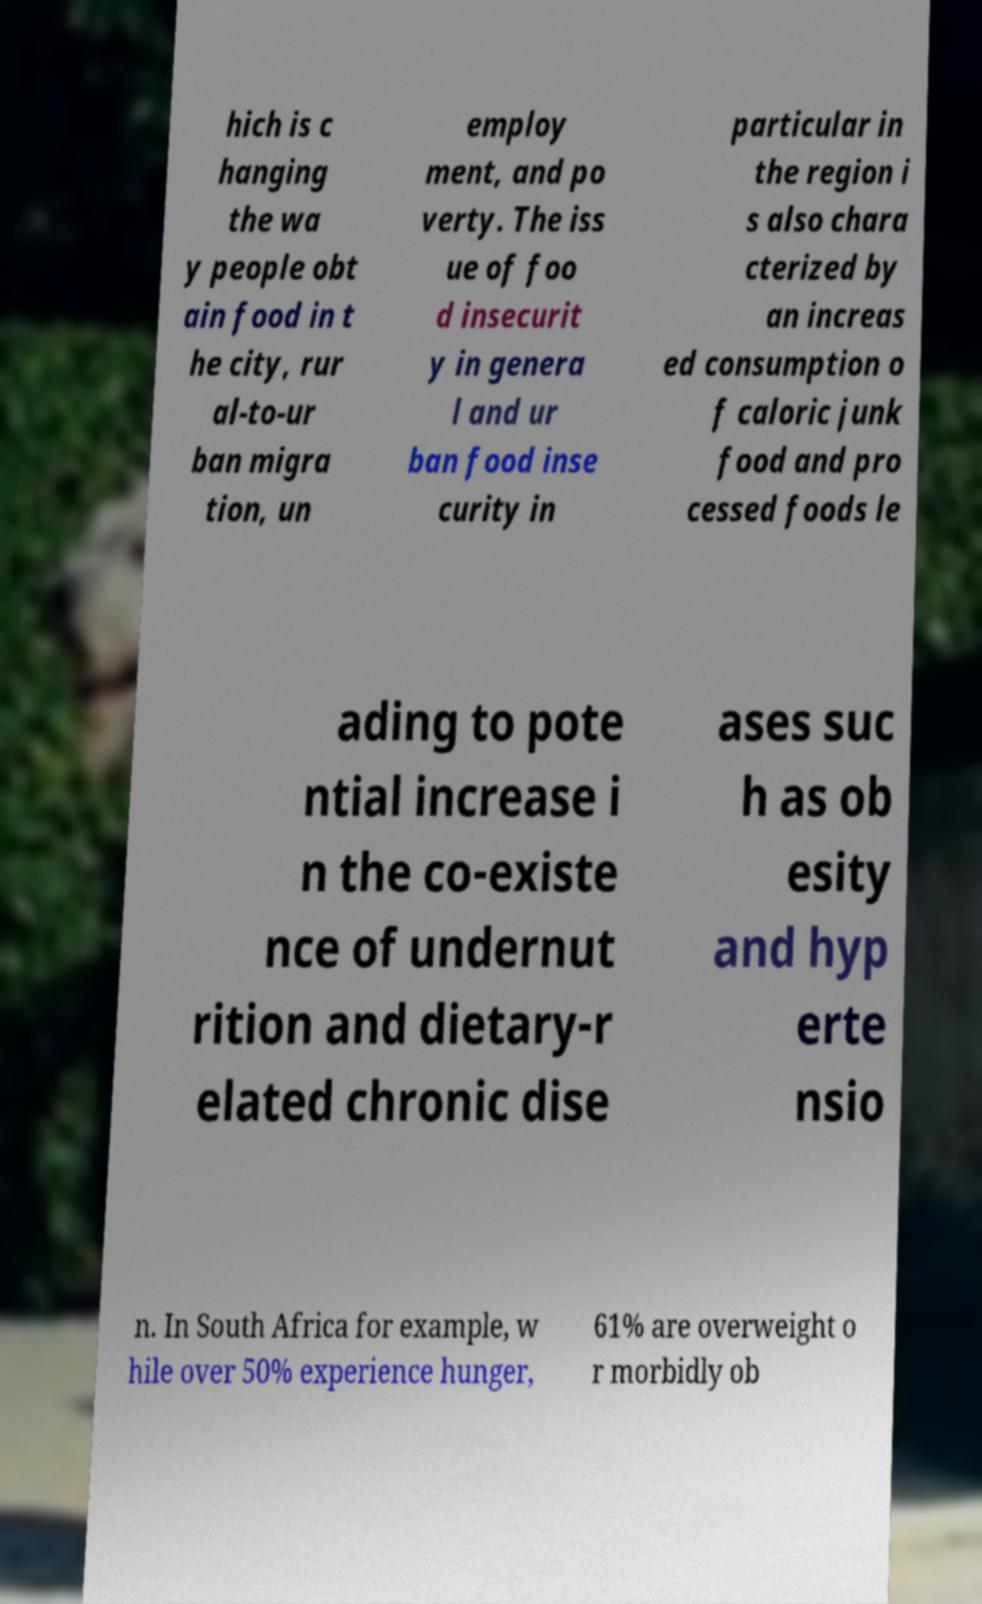Can you read and provide the text displayed in the image?This photo seems to have some interesting text. Can you extract and type it out for me? hich is c hanging the wa y people obt ain food in t he city, rur al-to-ur ban migra tion, un employ ment, and po verty. The iss ue of foo d insecurit y in genera l and ur ban food inse curity in particular in the region i s also chara cterized by an increas ed consumption o f caloric junk food and pro cessed foods le ading to pote ntial increase i n the co-existe nce of undernut rition and dietary-r elated chronic dise ases suc h as ob esity and hyp erte nsio n. In South Africa for example, w hile over 50% experience hunger, 61% are overweight o r morbidly ob 